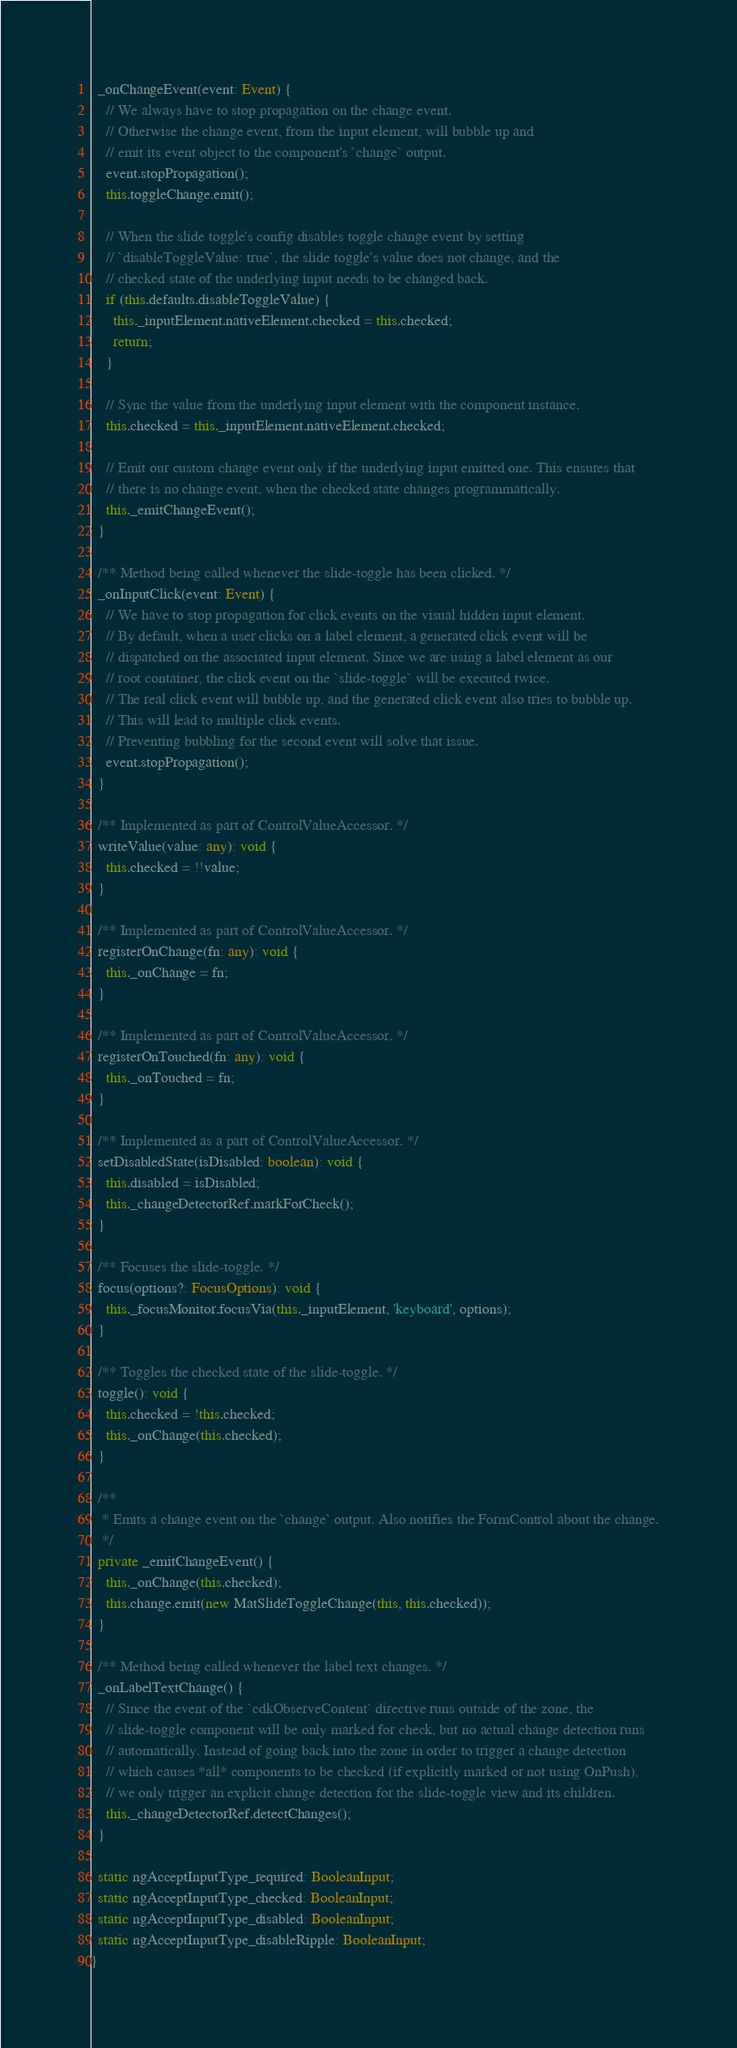Convert code to text. <code><loc_0><loc_0><loc_500><loc_500><_TypeScript_>  _onChangeEvent(event: Event) {
    // We always have to stop propagation on the change event.
    // Otherwise the change event, from the input element, will bubble up and
    // emit its event object to the component's `change` output.
    event.stopPropagation();
    this.toggleChange.emit();

    // When the slide toggle's config disables toggle change event by setting
    // `disableToggleValue: true`, the slide toggle's value does not change, and the
    // checked state of the underlying input needs to be changed back.
    if (this.defaults.disableToggleValue) {
      this._inputElement.nativeElement.checked = this.checked;
      return;
    }

    // Sync the value from the underlying input element with the component instance.
    this.checked = this._inputElement.nativeElement.checked;

    // Emit our custom change event only if the underlying input emitted one. This ensures that
    // there is no change event, when the checked state changes programmatically.
    this._emitChangeEvent();
  }

  /** Method being called whenever the slide-toggle has been clicked. */
  _onInputClick(event: Event) {
    // We have to stop propagation for click events on the visual hidden input element.
    // By default, when a user clicks on a label element, a generated click event will be
    // dispatched on the associated input element. Since we are using a label element as our
    // root container, the click event on the `slide-toggle` will be executed twice.
    // The real click event will bubble up, and the generated click event also tries to bubble up.
    // This will lead to multiple click events.
    // Preventing bubbling for the second event will solve that issue.
    event.stopPropagation();
  }

  /** Implemented as part of ControlValueAccessor. */
  writeValue(value: any): void {
    this.checked = !!value;
  }

  /** Implemented as part of ControlValueAccessor. */
  registerOnChange(fn: any): void {
    this._onChange = fn;
  }

  /** Implemented as part of ControlValueAccessor. */
  registerOnTouched(fn: any): void {
    this._onTouched = fn;
  }

  /** Implemented as a part of ControlValueAccessor. */
  setDisabledState(isDisabled: boolean): void {
    this.disabled = isDisabled;
    this._changeDetectorRef.markForCheck();
  }

  /** Focuses the slide-toggle. */
  focus(options?: FocusOptions): void {
    this._focusMonitor.focusVia(this._inputElement, 'keyboard', options);
  }

  /** Toggles the checked state of the slide-toggle. */
  toggle(): void {
    this.checked = !this.checked;
    this._onChange(this.checked);
  }

  /**
   * Emits a change event on the `change` output. Also notifies the FormControl about the change.
   */
  private _emitChangeEvent() {
    this._onChange(this.checked);
    this.change.emit(new MatSlideToggleChange(this, this.checked));
  }

  /** Method being called whenever the label text changes. */
  _onLabelTextChange() {
    // Since the event of the `cdkObserveContent` directive runs outside of the zone, the
    // slide-toggle component will be only marked for check, but no actual change detection runs
    // automatically. Instead of going back into the zone in order to trigger a change detection
    // which causes *all* components to be checked (if explicitly marked or not using OnPush),
    // we only trigger an explicit change detection for the slide-toggle view and its children.
    this._changeDetectorRef.detectChanges();
  }

  static ngAcceptInputType_required: BooleanInput;
  static ngAcceptInputType_checked: BooleanInput;
  static ngAcceptInputType_disabled: BooleanInput;
  static ngAcceptInputType_disableRipple: BooleanInput;
}
</code> 